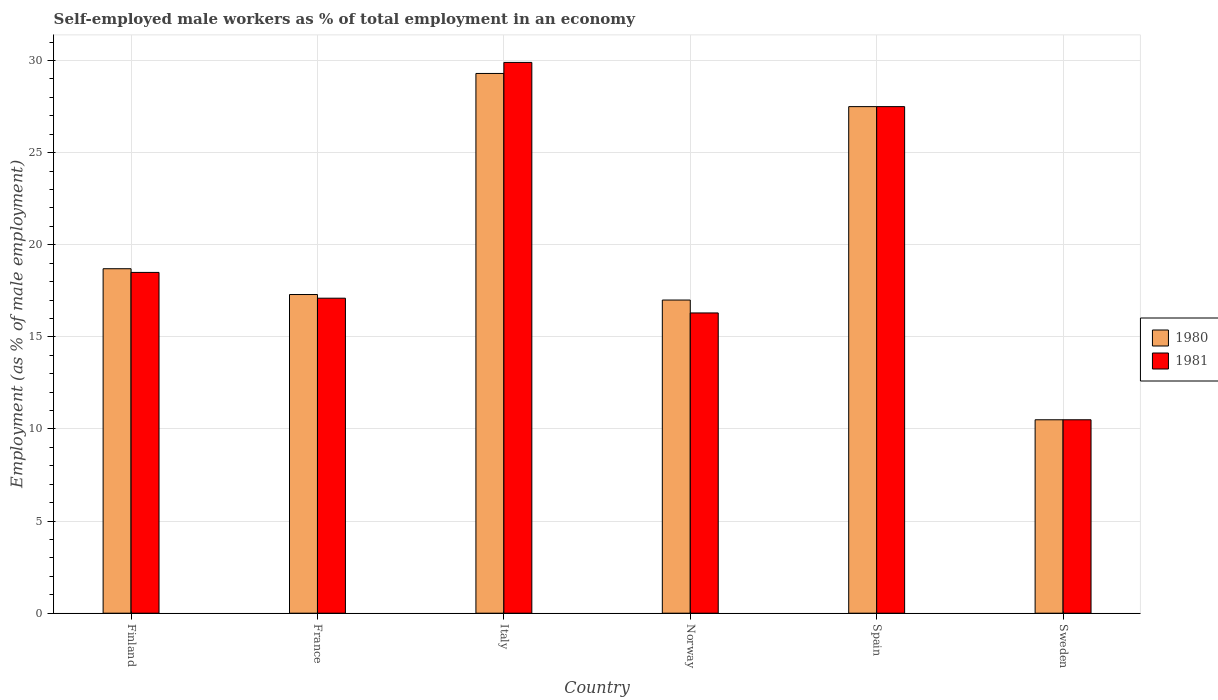How many groups of bars are there?
Keep it short and to the point. 6. Are the number of bars per tick equal to the number of legend labels?
Keep it short and to the point. Yes. How many bars are there on the 4th tick from the right?
Keep it short and to the point. 2. In how many cases, is the number of bars for a given country not equal to the number of legend labels?
Provide a succinct answer. 0. What is the percentage of self-employed male workers in 1980 in Italy?
Your answer should be compact. 29.3. Across all countries, what is the maximum percentage of self-employed male workers in 1981?
Give a very brief answer. 29.9. Across all countries, what is the minimum percentage of self-employed male workers in 1981?
Your response must be concise. 10.5. In which country was the percentage of self-employed male workers in 1980 minimum?
Provide a succinct answer. Sweden. What is the total percentage of self-employed male workers in 1980 in the graph?
Your answer should be compact. 120.3. What is the difference between the percentage of self-employed male workers in 1981 in France and that in Spain?
Your response must be concise. -10.4. What is the difference between the percentage of self-employed male workers in 1981 in Sweden and the percentage of self-employed male workers in 1980 in Norway?
Ensure brevity in your answer.  -6.5. What is the average percentage of self-employed male workers in 1981 per country?
Offer a very short reply. 19.97. What is the difference between the percentage of self-employed male workers of/in 1981 and percentage of self-employed male workers of/in 1980 in Italy?
Give a very brief answer. 0.6. What is the ratio of the percentage of self-employed male workers in 1980 in Italy to that in Spain?
Keep it short and to the point. 1.07. What is the difference between the highest and the second highest percentage of self-employed male workers in 1980?
Offer a terse response. -8.8. What is the difference between the highest and the lowest percentage of self-employed male workers in 1980?
Make the answer very short. 18.8. What does the 2nd bar from the left in Italy represents?
Make the answer very short. 1981. What does the 1st bar from the right in Spain represents?
Provide a succinct answer. 1981. Are all the bars in the graph horizontal?
Provide a succinct answer. No. How many countries are there in the graph?
Your answer should be very brief. 6. What is the difference between two consecutive major ticks on the Y-axis?
Keep it short and to the point. 5. Does the graph contain any zero values?
Offer a terse response. No. Does the graph contain grids?
Offer a terse response. Yes. Where does the legend appear in the graph?
Your answer should be compact. Center right. How many legend labels are there?
Offer a very short reply. 2. What is the title of the graph?
Your answer should be very brief. Self-employed male workers as % of total employment in an economy. What is the label or title of the Y-axis?
Your answer should be compact. Employment (as % of male employment). What is the Employment (as % of male employment) in 1980 in Finland?
Offer a very short reply. 18.7. What is the Employment (as % of male employment) of 1981 in Finland?
Offer a terse response. 18.5. What is the Employment (as % of male employment) in 1980 in France?
Ensure brevity in your answer.  17.3. What is the Employment (as % of male employment) in 1981 in France?
Ensure brevity in your answer.  17.1. What is the Employment (as % of male employment) of 1980 in Italy?
Your answer should be compact. 29.3. What is the Employment (as % of male employment) in 1981 in Italy?
Provide a succinct answer. 29.9. What is the Employment (as % of male employment) in 1980 in Norway?
Ensure brevity in your answer.  17. What is the Employment (as % of male employment) in 1981 in Norway?
Ensure brevity in your answer.  16.3. What is the Employment (as % of male employment) of 1980 in Spain?
Ensure brevity in your answer.  27.5. What is the Employment (as % of male employment) of 1981 in Spain?
Provide a succinct answer. 27.5. What is the Employment (as % of male employment) of 1981 in Sweden?
Your answer should be compact. 10.5. Across all countries, what is the maximum Employment (as % of male employment) in 1980?
Provide a succinct answer. 29.3. Across all countries, what is the maximum Employment (as % of male employment) of 1981?
Your answer should be very brief. 29.9. Across all countries, what is the minimum Employment (as % of male employment) in 1981?
Offer a terse response. 10.5. What is the total Employment (as % of male employment) in 1980 in the graph?
Provide a succinct answer. 120.3. What is the total Employment (as % of male employment) in 1981 in the graph?
Your response must be concise. 119.8. What is the difference between the Employment (as % of male employment) in 1980 in Finland and that in Italy?
Provide a short and direct response. -10.6. What is the difference between the Employment (as % of male employment) in 1981 in Finland and that in Italy?
Ensure brevity in your answer.  -11.4. What is the difference between the Employment (as % of male employment) in 1980 in Finland and that in Norway?
Give a very brief answer. 1.7. What is the difference between the Employment (as % of male employment) in 1981 in Finland and that in Norway?
Offer a very short reply. 2.2. What is the difference between the Employment (as % of male employment) in 1980 in Finland and that in Spain?
Ensure brevity in your answer.  -8.8. What is the difference between the Employment (as % of male employment) in 1981 in Finland and that in Spain?
Ensure brevity in your answer.  -9. What is the difference between the Employment (as % of male employment) in 1980 in Finland and that in Sweden?
Your answer should be very brief. 8.2. What is the difference between the Employment (as % of male employment) of 1980 in France and that in Italy?
Ensure brevity in your answer.  -12. What is the difference between the Employment (as % of male employment) of 1981 in France and that in Norway?
Your response must be concise. 0.8. What is the difference between the Employment (as % of male employment) in 1980 in France and that in Spain?
Give a very brief answer. -10.2. What is the difference between the Employment (as % of male employment) of 1981 in Italy and that in Sweden?
Your response must be concise. 19.4. What is the difference between the Employment (as % of male employment) of 1980 in Norway and that in Sweden?
Offer a terse response. 6.5. What is the difference between the Employment (as % of male employment) in 1980 in Finland and the Employment (as % of male employment) in 1981 in Italy?
Ensure brevity in your answer.  -11.2. What is the difference between the Employment (as % of male employment) in 1980 in Finland and the Employment (as % of male employment) in 1981 in Norway?
Give a very brief answer. 2.4. What is the difference between the Employment (as % of male employment) in 1980 in France and the Employment (as % of male employment) in 1981 in Italy?
Provide a succinct answer. -12.6. What is the difference between the Employment (as % of male employment) in 1980 in France and the Employment (as % of male employment) in 1981 in Sweden?
Offer a terse response. 6.8. What is the difference between the Employment (as % of male employment) of 1980 in Italy and the Employment (as % of male employment) of 1981 in Spain?
Give a very brief answer. 1.8. What is the difference between the Employment (as % of male employment) of 1980 in Norway and the Employment (as % of male employment) of 1981 in Sweden?
Offer a terse response. 6.5. What is the average Employment (as % of male employment) of 1980 per country?
Provide a succinct answer. 20.05. What is the average Employment (as % of male employment) in 1981 per country?
Keep it short and to the point. 19.97. What is the difference between the Employment (as % of male employment) of 1980 and Employment (as % of male employment) of 1981 in Norway?
Keep it short and to the point. 0.7. What is the ratio of the Employment (as % of male employment) of 1980 in Finland to that in France?
Offer a terse response. 1.08. What is the ratio of the Employment (as % of male employment) of 1981 in Finland to that in France?
Offer a very short reply. 1.08. What is the ratio of the Employment (as % of male employment) of 1980 in Finland to that in Italy?
Your response must be concise. 0.64. What is the ratio of the Employment (as % of male employment) of 1981 in Finland to that in Italy?
Your answer should be compact. 0.62. What is the ratio of the Employment (as % of male employment) of 1981 in Finland to that in Norway?
Your response must be concise. 1.14. What is the ratio of the Employment (as % of male employment) of 1980 in Finland to that in Spain?
Keep it short and to the point. 0.68. What is the ratio of the Employment (as % of male employment) in 1981 in Finland to that in Spain?
Give a very brief answer. 0.67. What is the ratio of the Employment (as % of male employment) in 1980 in Finland to that in Sweden?
Your answer should be compact. 1.78. What is the ratio of the Employment (as % of male employment) of 1981 in Finland to that in Sweden?
Keep it short and to the point. 1.76. What is the ratio of the Employment (as % of male employment) of 1980 in France to that in Italy?
Make the answer very short. 0.59. What is the ratio of the Employment (as % of male employment) in 1981 in France to that in Italy?
Give a very brief answer. 0.57. What is the ratio of the Employment (as % of male employment) of 1980 in France to that in Norway?
Give a very brief answer. 1.02. What is the ratio of the Employment (as % of male employment) of 1981 in France to that in Norway?
Provide a short and direct response. 1.05. What is the ratio of the Employment (as % of male employment) in 1980 in France to that in Spain?
Offer a very short reply. 0.63. What is the ratio of the Employment (as % of male employment) in 1981 in France to that in Spain?
Offer a very short reply. 0.62. What is the ratio of the Employment (as % of male employment) in 1980 in France to that in Sweden?
Your answer should be very brief. 1.65. What is the ratio of the Employment (as % of male employment) in 1981 in France to that in Sweden?
Provide a short and direct response. 1.63. What is the ratio of the Employment (as % of male employment) of 1980 in Italy to that in Norway?
Keep it short and to the point. 1.72. What is the ratio of the Employment (as % of male employment) of 1981 in Italy to that in Norway?
Offer a very short reply. 1.83. What is the ratio of the Employment (as % of male employment) of 1980 in Italy to that in Spain?
Your answer should be compact. 1.07. What is the ratio of the Employment (as % of male employment) of 1981 in Italy to that in Spain?
Keep it short and to the point. 1.09. What is the ratio of the Employment (as % of male employment) in 1980 in Italy to that in Sweden?
Ensure brevity in your answer.  2.79. What is the ratio of the Employment (as % of male employment) of 1981 in Italy to that in Sweden?
Your answer should be very brief. 2.85. What is the ratio of the Employment (as % of male employment) of 1980 in Norway to that in Spain?
Your response must be concise. 0.62. What is the ratio of the Employment (as % of male employment) of 1981 in Norway to that in Spain?
Provide a short and direct response. 0.59. What is the ratio of the Employment (as % of male employment) in 1980 in Norway to that in Sweden?
Your answer should be very brief. 1.62. What is the ratio of the Employment (as % of male employment) in 1981 in Norway to that in Sweden?
Offer a terse response. 1.55. What is the ratio of the Employment (as % of male employment) of 1980 in Spain to that in Sweden?
Give a very brief answer. 2.62. What is the ratio of the Employment (as % of male employment) of 1981 in Spain to that in Sweden?
Your answer should be compact. 2.62. 